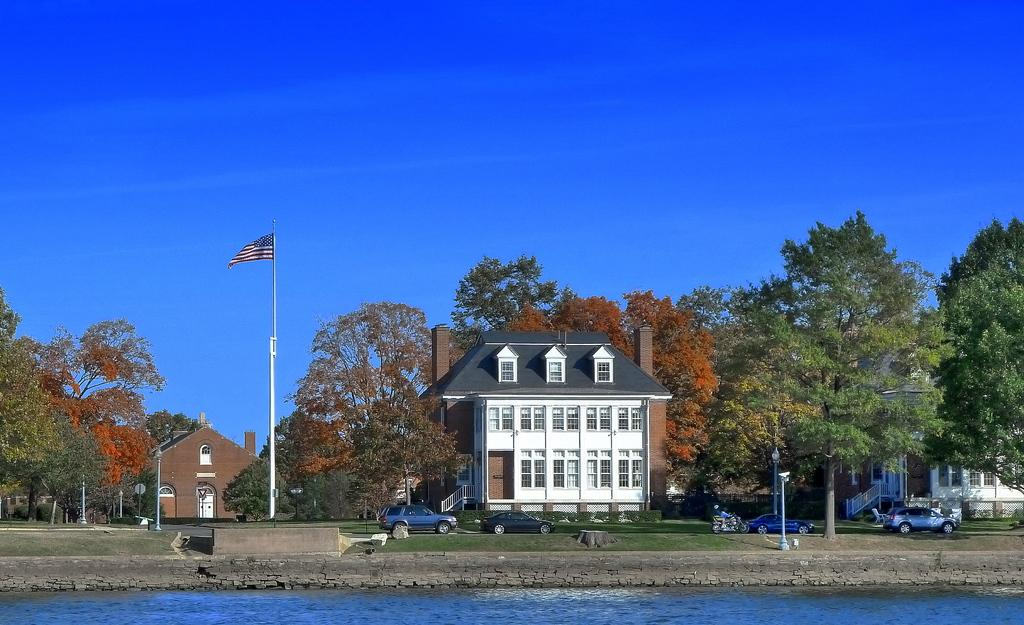What type of structures can be seen in the image? There are buildings in the image. How are the buildings positioned in relation to the trees? The buildings are situated between trees. What is located in the middle of the image? There is a pole in the middle of the image. Where are the cars located in the image? The cars are beside a lake in the image. What can be seen in the background of the image? The sky is visible in the background of the image. What type of pipe can be seen running through the stream in the image? There is no stream or pipe present in the image. 